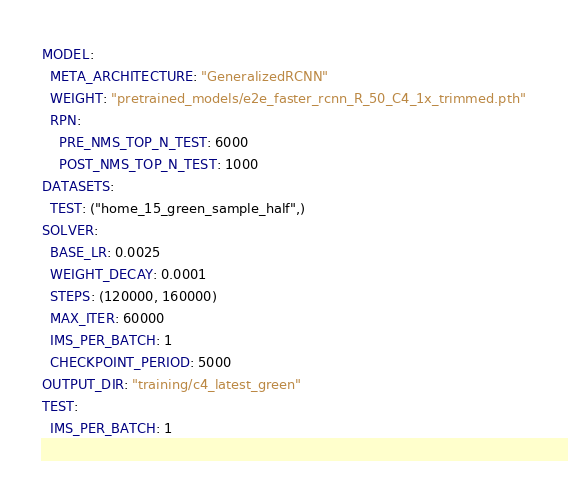<code> <loc_0><loc_0><loc_500><loc_500><_YAML_>MODEL:
  META_ARCHITECTURE: "GeneralizedRCNN"
  WEIGHT: "pretrained_models/e2e_faster_rcnn_R_50_C4_1x_trimmed.pth"
  RPN:
    PRE_NMS_TOP_N_TEST: 6000
    POST_NMS_TOP_N_TEST: 1000
DATASETS:
  TEST: ("home_15_green_sample_half",)
SOLVER:
  BASE_LR: 0.0025
  WEIGHT_DECAY: 0.0001
  STEPS: (120000, 160000)
  MAX_ITER: 60000
  IMS_PER_BATCH: 1
  CHECKPOINT_PERIOD: 5000
OUTPUT_DIR: "training/c4_latest_green"
TEST:
  IMS_PER_BATCH: 1</code> 